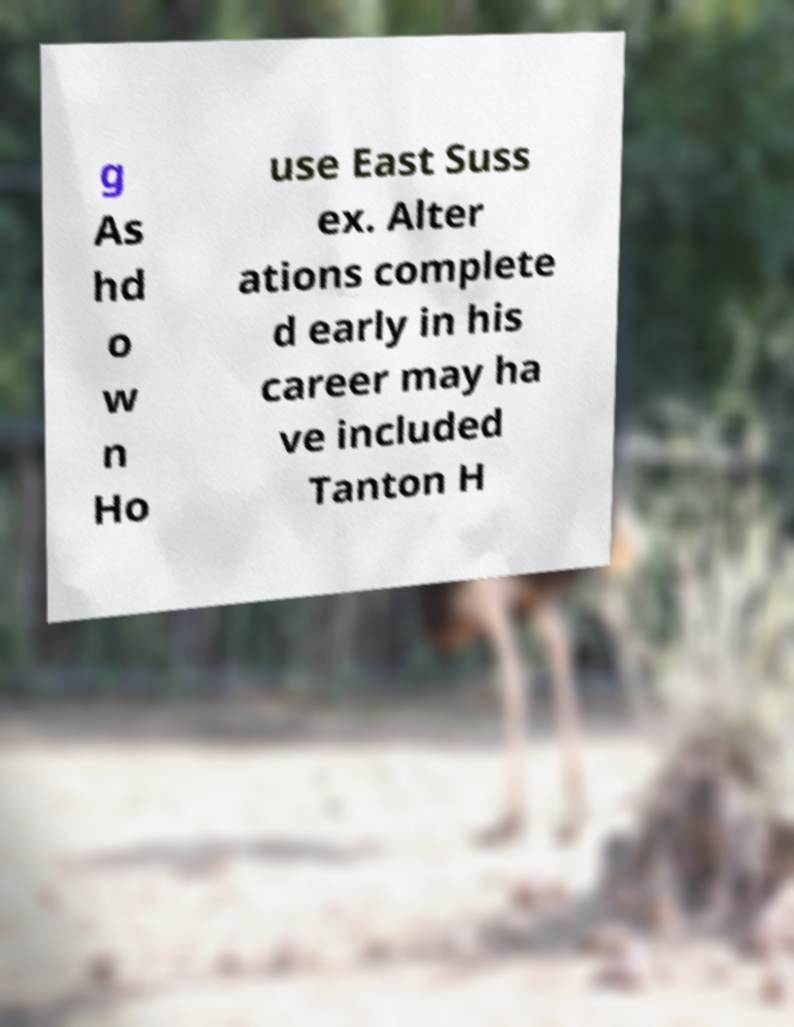Please identify and transcribe the text found in this image. g As hd o w n Ho use East Suss ex. Alter ations complete d early in his career may ha ve included Tanton H 